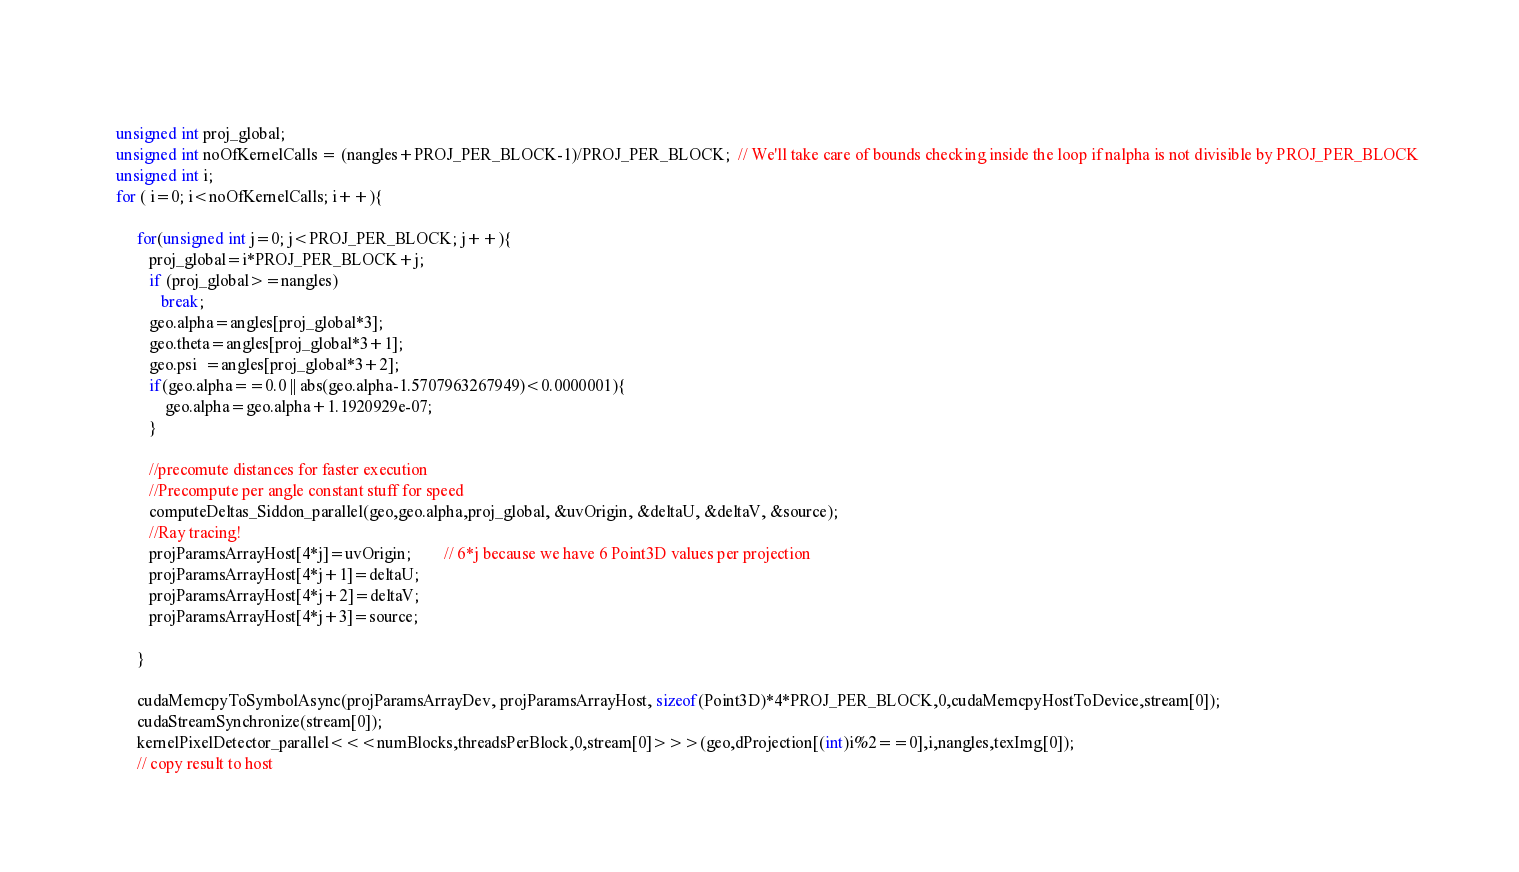<code> <loc_0><loc_0><loc_500><loc_500><_Cuda_>    
    unsigned int proj_global;
    unsigned int noOfKernelCalls = (nangles+PROJ_PER_BLOCK-1)/PROJ_PER_BLOCK;  // We'll take care of bounds checking inside the loop if nalpha is not divisible by PROJ_PER_BLOCK
    unsigned int i;
    for ( i=0; i<noOfKernelCalls; i++){
        
         for(unsigned int j=0; j<PROJ_PER_BLOCK; j++){
            proj_global=i*PROJ_PER_BLOCK+j;
            if (proj_global>=nangles)
               break;
            geo.alpha=angles[proj_global*3];
            geo.theta=angles[proj_global*3+1];
            geo.psi  =angles[proj_global*3+2];
            if(geo.alpha==0.0 || abs(geo.alpha-1.5707963267949)<0.0000001){
                geo.alpha=geo.alpha+1.1920929e-07;
            }
            
            //precomute distances for faster execution
            //Precompute per angle constant stuff for speed
            computeDeltas_Siddon_parallel(geo,geo.alpha,proj_global, &uvOrigin, &deltaU, &deltaV, &source);
            //Ray tracing!
            projParamsArrayHost[4*j]=uvOrigin;		// 6*j because we have 6 Point3D values per projection
            projParamsArrayHost[4*j+1]=deltaU;
            projParamsArrayHost[4*j+2]=deltaV;
            projParamsArrayHost[4*j+3]=source;

         }
         
         cudaMemcpyToSymbolAsync(projParamsArrayDev, projParamsArrayHost, sizeof(Point3D)*4*PROJ_PER_BLOCK,0,cudaMemcpyHostToDevice,stream[0]);
         cudaStreamSynchronize(stream[0]);
         kernelPixelDetector_parallel<<<numBlocks,threadsPerBlock,0,stream[0]>>>(geo,dProjection[(int)i%2==0],i,nangles,texImg[0]);
         // copy result to host</code> 